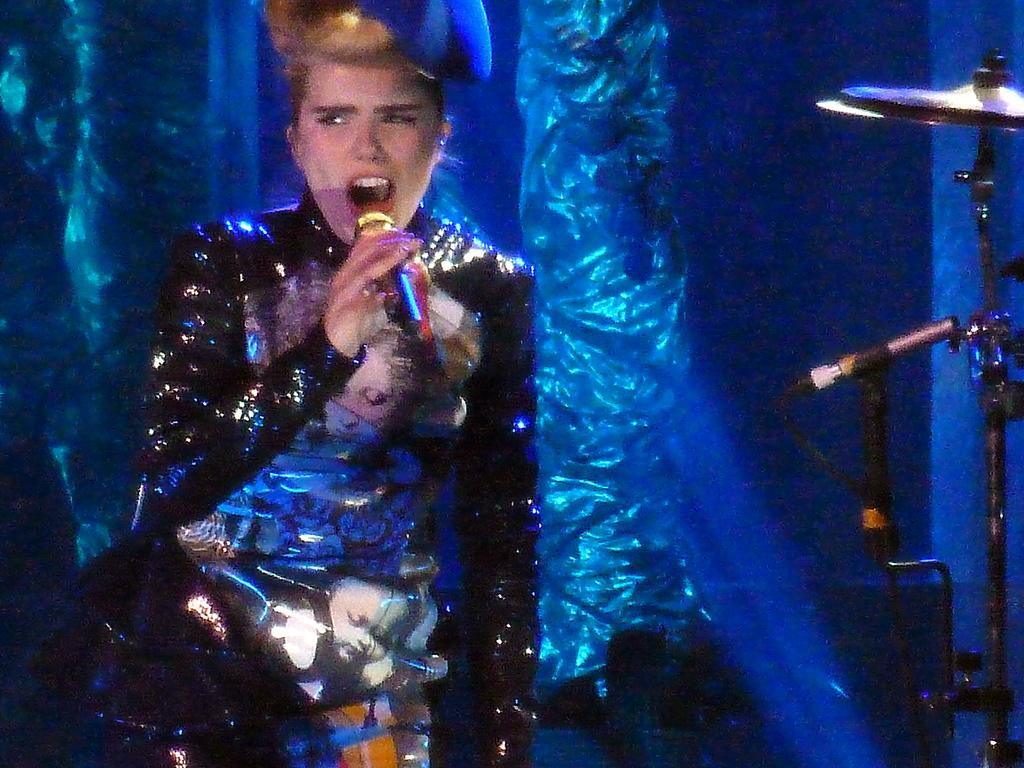What is the person in the image doing? The person is standing and holding a mic. What might the person be doing with the mic? The person might be singing or speaking into the mic. What else can be seen on the right side of the image? There is a band on the right side of the image. What type of soup is being served in the image? There is no soup present in the image. What kind of art can be seen on the walls in the image? There is no mention of any art or walls in the image. 